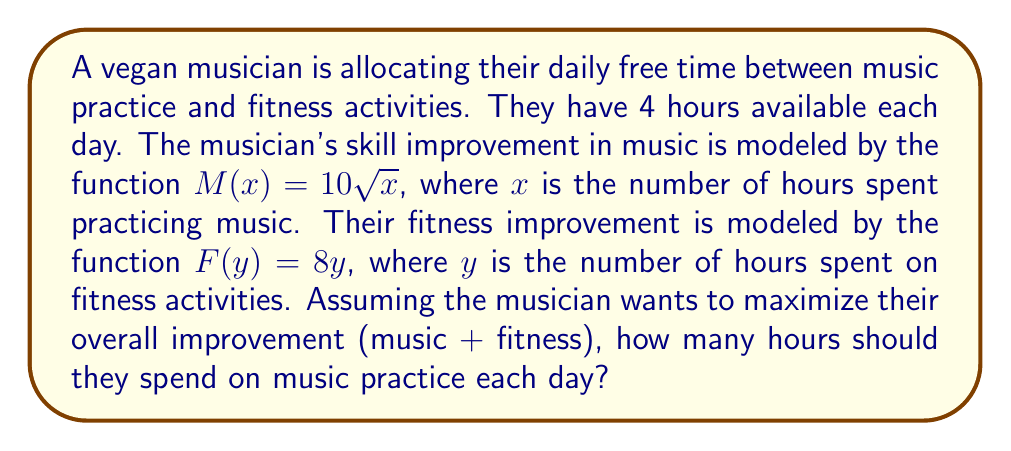Can you answer this question? Let's approach this step-by-step using game theory concepts:

1) First, we need to set up our constraint equation. The total time available is 4 hours, so:
   $x + y = 4$, where $x$ is time spent on music and $y$ is time spent on fitness.

2) We want to maximize the total improvement, which is represented by:
   $T(x) = M(x) + F(y) = 10\sqrt{x} + 8y$

3) Substituting $y = 4 - x$ from our constraint equation:
   $T(x) = 10\sqrt{x} + 8(4-x) = 10\sqrt{x} + 32 - 8x$

4) To find the maximum value of $T(x)$, we need to find where its derivative equals zero:
   $\frac{dT}{dx} = \frac{10}{2\sqrt{x}} - 8 = \frac{5}{\sqrt{x}} - 8 = 0$

5) Solving this equation:
   $\frac{5}{\sqrt{x}} = 8$
   $5 = 8\sqrt{x}$
   $\frac{25}{64} = x$

6) To confirm this is a maximum, we can check the second derivative:
   $\frac{d^2T}{dx^2} = -\frac{5}{2x^{3/2}}$, which is negative for positive $x$, confirming a maximum.

7) Therefore, the optimal time spent on music practice is $\frac{25}{64} = 0.390625$ hours, or about 23.4375 minutes.

8) The remaining time, $4 - \frac{25}{64} = \frac{231}{64} = 3.609375$ hours (or about 3 hours and 36.5625 minutes), should be spent on fitness activities.
Answer: The musician should spend $\frac{25}{64}$ hours (approximately 23.4375 minutes) on music practice each day to maximize their overall improvement. 